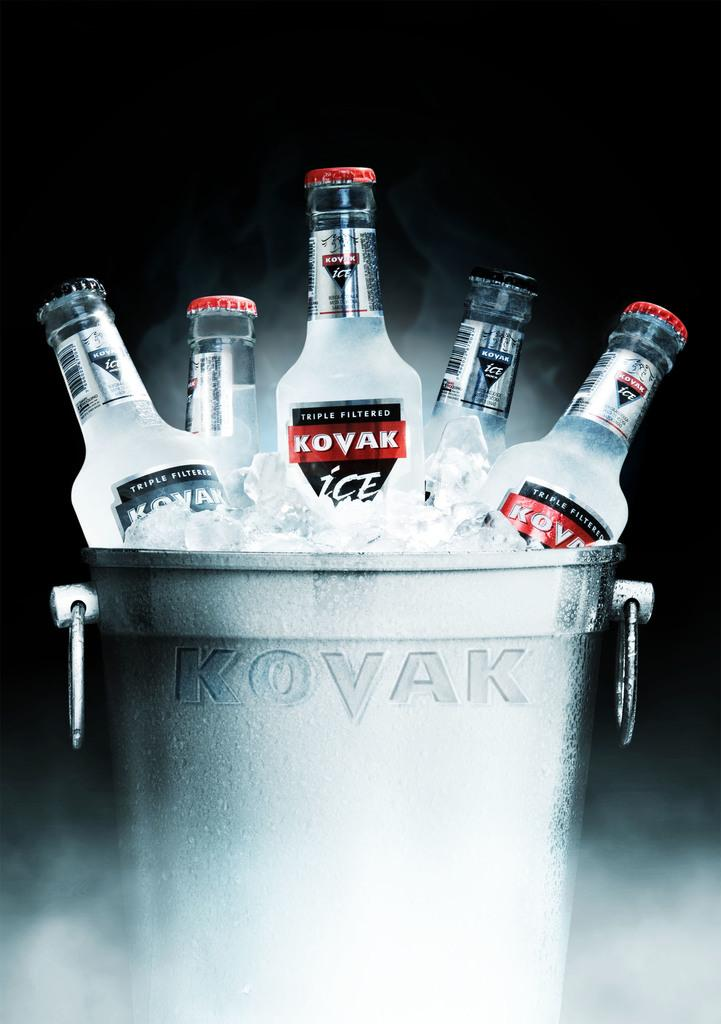<image>
Present a compact description of the photo's key features. Bottles of Kovak sitting in ice inside of a cooler. 